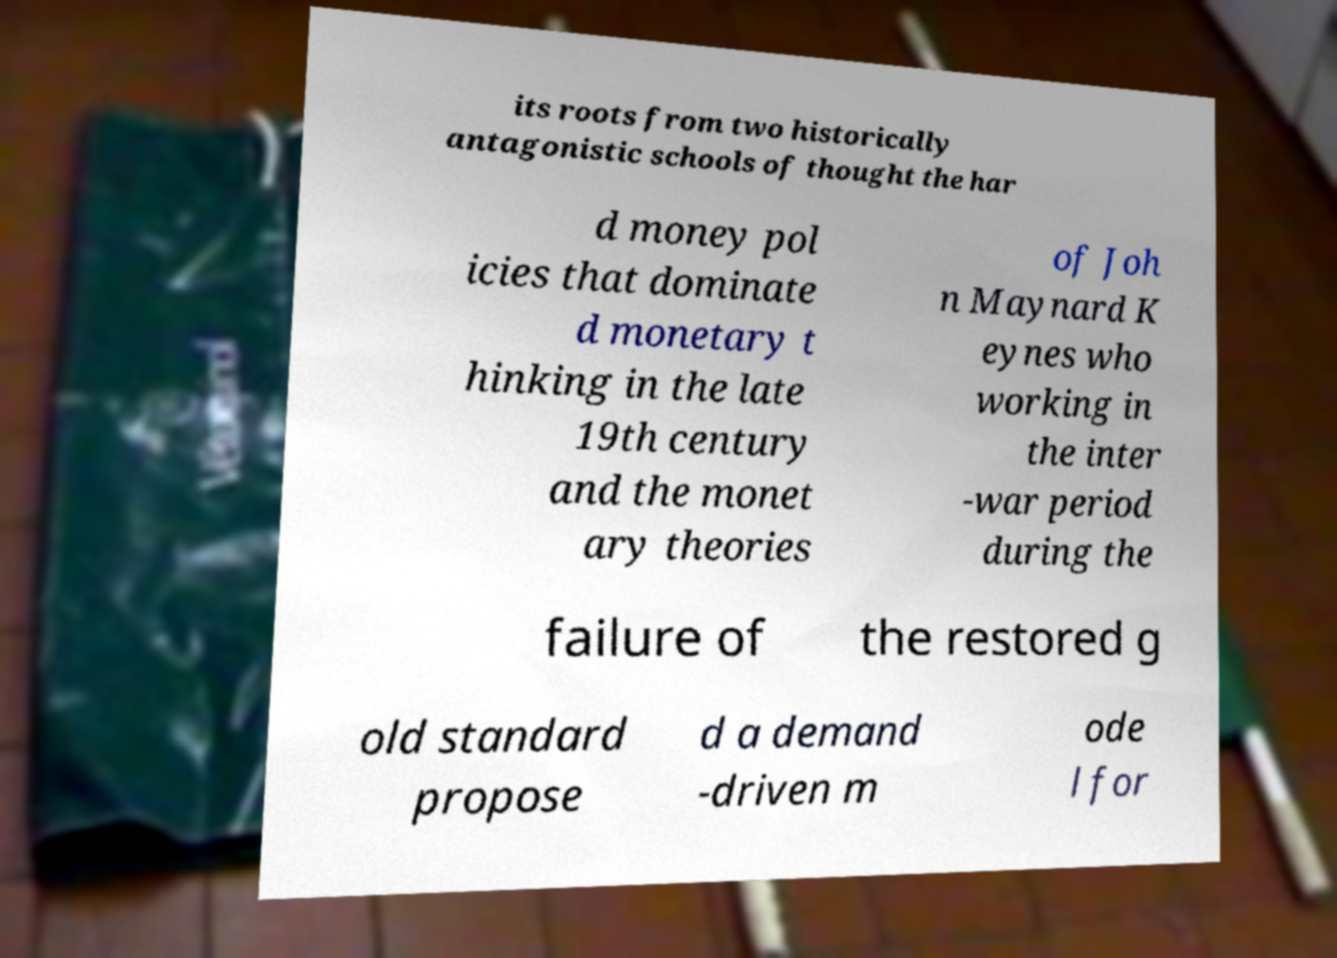I need the written content from this picture converted into text. Can you do that? its roots from two historically antagonistic schools of thought the har d money pol icies that dominate d monetary t hinking in the late 19th century and the monet ary theories of Joh n Maynard K eynes who working in the inter -war period during the failure of the restored g old standard propose d a demand -driven m ode l for 